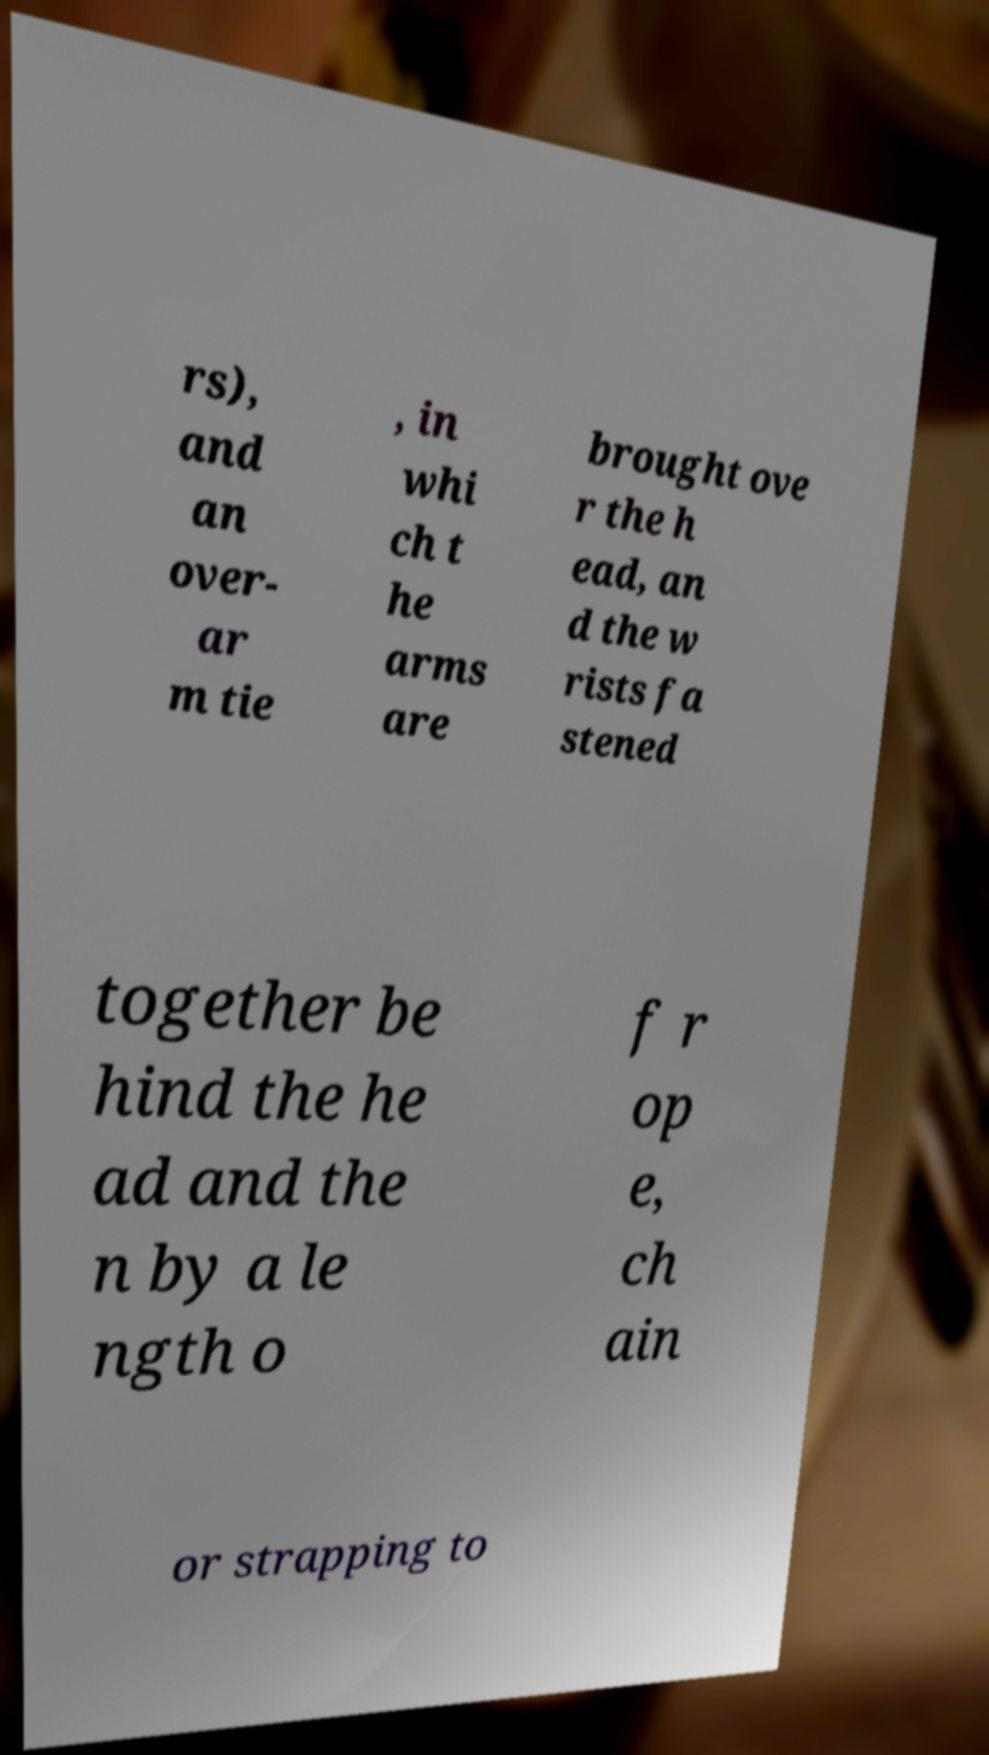For documentation purposes, I need the text within this image transcribed. Could you provide that? rs), and an over- ar m tie , in whi ch t he arms are brought ove r the h ead, an d the w rists fa stened together be hind the he ad and the n by a le ngth o f r op e, ch ain or strapping to 